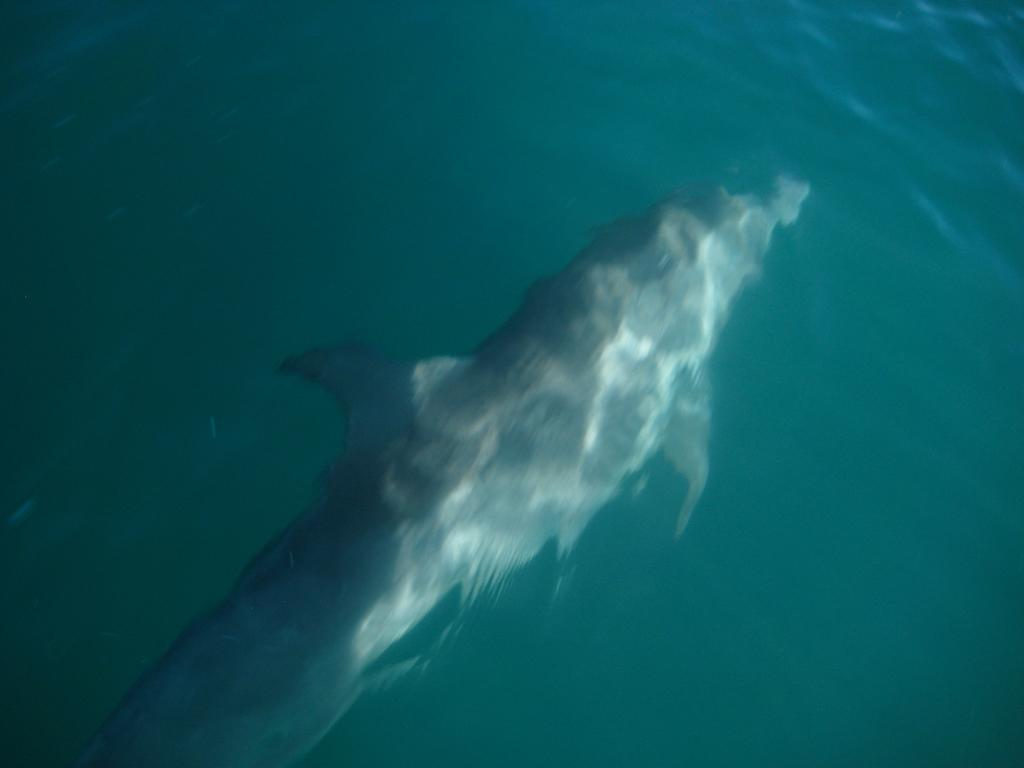What type of animal is the main subject of the image? There is a big fish in the image. Where is the fish located? The fish is under water. What color is the water in the image? The water is blue. What type of flag is visible in the image? There is no flag present in the image; it features a big fish under blue water. How does the acoustics of the water affect the sound of the fish swimming in the image? The image does not provide information about the acoustics of the water or the sound of the fish swimming. 